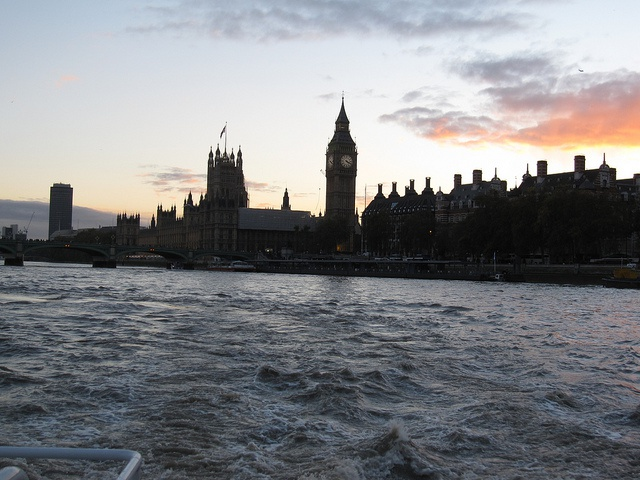Describe the objects in this image and their specific colors. I can see boat in darkgray, black, darkblue, and blue tones, boat in darkgray, black, and gray tones, boat in darkgray, black, gray, and darkblue tones, clock in darkgray, gray, and black tones, and clock in darkgray, gray, and black tones in this image. 